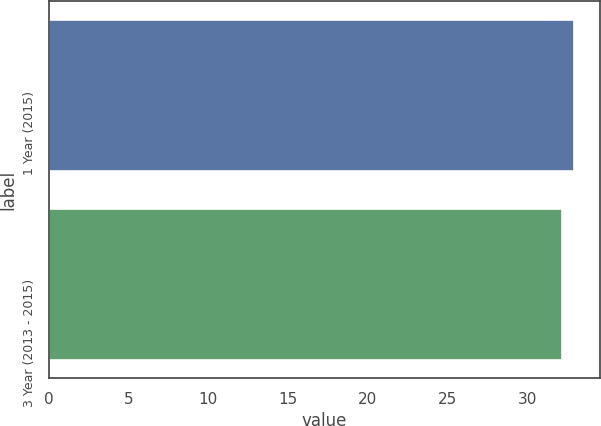Convert chart to OTSL. <chart><loc_0><loc_0><loc_500><loc_500><bar_chart><fcel>1 Year (2015)<fcel>3 Year (2013 - 2015)<nl><fcel>32.9<fcel>32.2<nl></chart> 